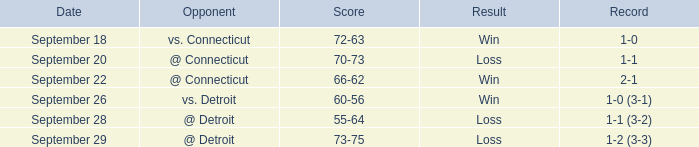WHAT IS THE SCORE WITH A RECORD OF 1-0? 72-63. 